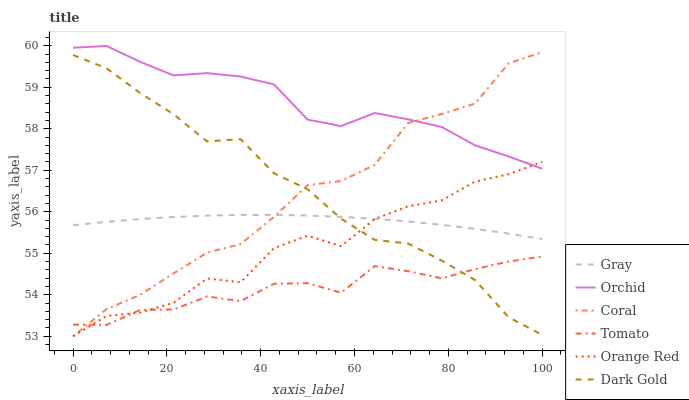Does Tomato have the minimum area under the curve?
Answer yes or no. Yes. Does Orchid have the maximum area under the curve?
Answer yes or no. Yes. Does Gray have the minimum area under the curve?
Answer yes or no. No. Does Gray have the maximum area under the curve?
Answer yes or no. No. Is Gray the smoothest?
Answer yes or no. Yes. Is Orange Red the roughest?
Answer yes or no. Yes. Is Dark Gold the smoothest?
Answer yes or no. No. Is Dark Gold the roughest?
Answer yes or no. No. Does Coral have the lowest value?
Answer yes or no. Yes. Does Gray have the lowest value?
Answer yes or no. No. Does Orchid have the highest value?
Answer yes or no. Yes. Does Gray have the highest value?
Answer yes or no. No. Is Tomato less than Gray?
Answer yes or no. Yes. Is Orchid greater than Gray?
Answer yes or no. Yes. Does Orange Red intersect Dark Gold?
Answer yes or no. Yes. Is Orange Red less than Dark Gold?
Answer yes or no. No. Is Orange Red greater than Dark Gold?
Answer yes or no. No. Does Tomato intersect Gray?
Answer yes or no. No. 